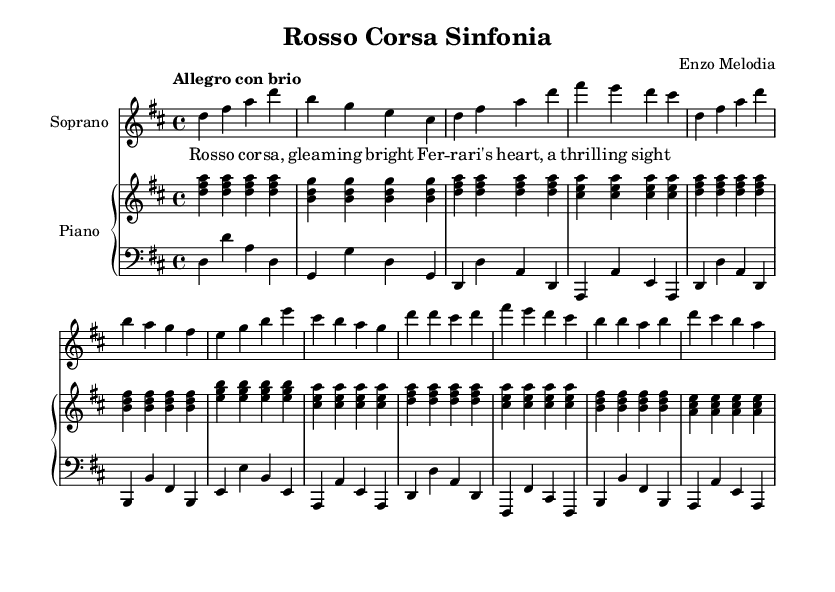What is the key signature of this music? The key signature is indicated at the beginning of the staff, showing two sharps, which corresponds to D major.
Answer: D major What is the time signature of this composition? The time signature appears at the beginning of the piece, showing 4 over 4, which means four beats per measure.
Answer: 4/4 What is the tempo marking for this piece? The tempo is written above the music, specifying "Allegro con brio," indicating a fast and lively speed.
Answer: Allegro con brio How many measures are in the soprano section? Counting the measures in the soprano line, there are a total of 16 measures provided in the excerpt.
Answer: 16 measures In the soprano verse, which word follows "Rosso"? The lyrics under the soprano part indicate "cor" directly follows "Rosso."
Answer: cor What instrument accompanies the singer in this piece? The accompaniment is provided by the piano, which is indicated by the "Piano" label above the staves.
Answer: Piano What is the primary theme of the lyrics in this aria? The lyrics express admiration and beauty, celebrating classic sports cars, specifically the Ferrari.
Answer: Beauty of classic sports cars 